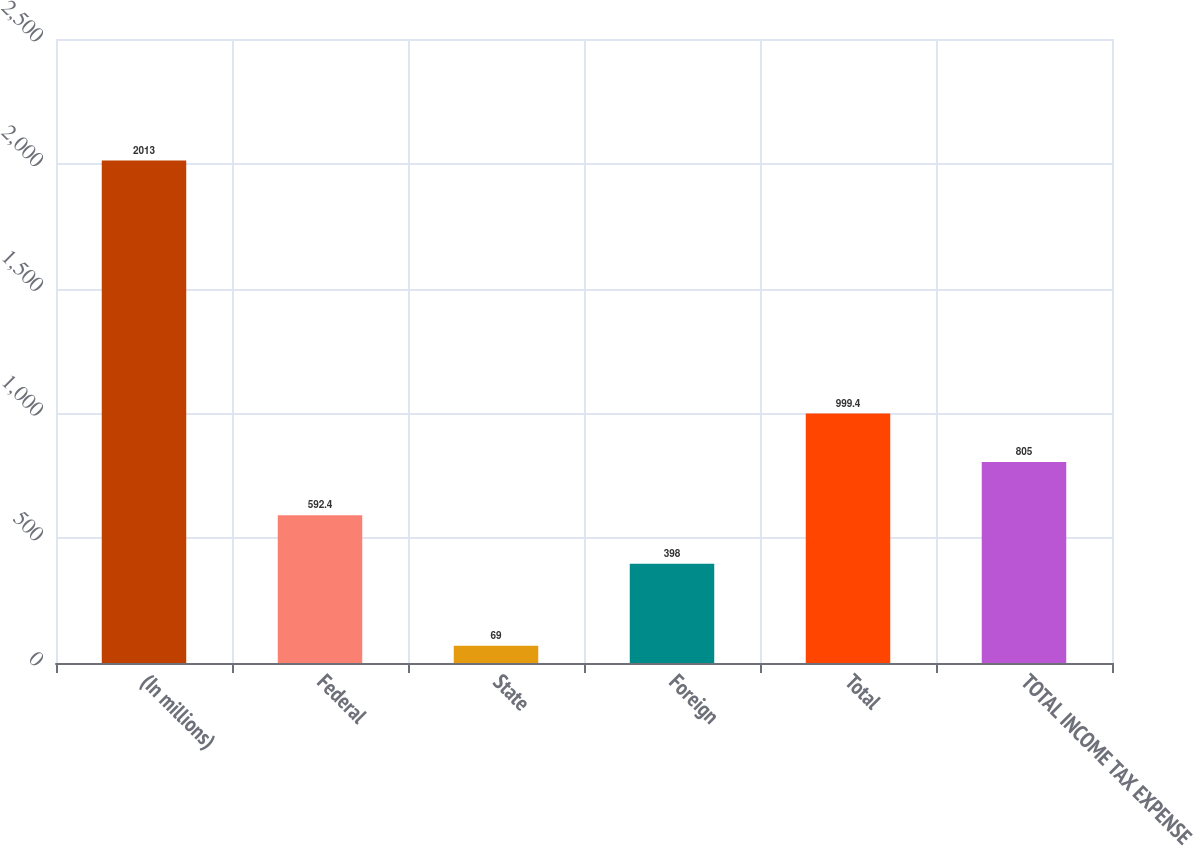Convert chart to OTSL. <chart><loc_0><loc_0><loc_500><loc_500><bar_chart><fcel>(In millions)<fcel>Federal<fcel>State<fcel>Foreign<fcel>Total<fcel>TOTAL INCOME TAX EXPENSE<nl><fcel>2013<fcel>592.4<fcel>69<fcel>398<fcel>999.4<fcel>805<nl></chart> 